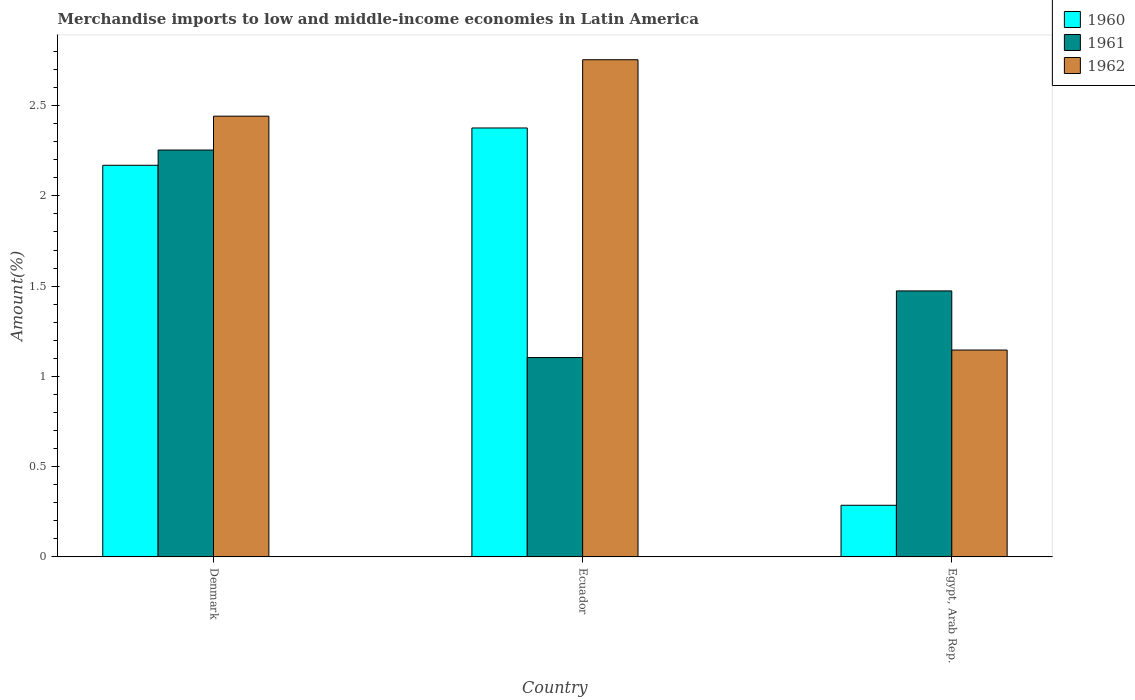Are the number of bars on each tick of the X-axis equal?
Your answer should be compact. Yes. What is the percentage of amount earned from merchandise imports in 1962 in Denmark?
Your response must be concise. 2.44. Across all countries, what is the maximum percentage of amount earned from merchandise imports in 1962?
Your answer should be very brief. 2.75. Across all countries, what is the minimum percentage of amount earned from merchandise imports in 1960?
Your response must be concise. 0.29. In which country was the percentage of amount earned from merchandise imports in 1960 maximum?
Your response must be concise. Ecuador. In which country was the percentage of amount earned from merchandise imports in 1961 minimum?
Give a very brief answer. Ecuador. What is the total percentage of amount earned from merchandise imports in 1960 in the graph?
Your response must be concise. 4.83. What is the difference between the percentage of amount earned from merchandise imports in 1960 in Denmark and that in Egypt, Arab Rep.?
Ensure brevity in your answer.  1.88. What is the difference between the percentage of amount earned from merchandise imports in 1961 in Denmark and the percentage of amount earned from merchandise imports in 1960 in Ecuador?
Ensure brevity in your answer.  -0.12. What is the average percentage of amount earned from merchandise imports in 1960 per country?
Your answer should be compact. 1.61. What is the difference between the percentage of amount earned from merchandise imports of/in 1962 and percentage of amount earned from merchandise imports of/in 1961 in Egypt, Arab Rep.?
Keep it short and to the point. -0.33. What is the ratio of the percentage of amount earned from merchandise imports in 1961 in Denmark to that in Ecuador?
Offer a terse response. 2.04. Is the percentage of amount earned from merchandise imports in 1960 in Denmark less than that in Egypt, Arab Rep.?
Your answer should be compact. No. What is the difference between the highest and the second highest percentage of amount earned from merchandise imports in 1962?
Offer a very short reply. -1.61. What is the difference between the highest and the lowest percentage of amount earned from merchandise imports in 1961?
Ensure brevity in your answer.  1.15. How many bars are there?
Make the answer very short. 9. How many countries are there in the graph?
Offer a very short reply. 3. What is the difference between two consecutive major ticks on the Y-axis?
Keep it short and to the point. 0.5. Are the values on the major ticks of Y-axis written in scientific E-notation?
Offer a terse response. No. Does the graph contain grids?
Offer a terse response. No. How many legend labels are there?
Offer a terse response. 3. How are the legend labels stacked?
Offer a very short reply. Vertical. What is the title of the graph?
Offer a very short reply. Merchandise imports to low and middle-income economies in Latin America. Does "1984" appear as one of the legend labels in the graph?
Provide a short and direct response. No. What is the label or title of the X-axis?
Give a very brief answer. Country. What is the label or title of the Y-axis?
Provide a short and direct response. Amount(%). What is the Amount(%) of 1960 in Denmark?
Give a very brief answer. 2.17. What is the Amount(%) of 1961 in Denmark?
Keep it short and to the point. 2.25. What is the Amount(%) in 1962 in Denmark?
Your response must be concise. 2.44. What is the Amount(%) in 1960 in Ecuador?
Your answer should be very brief. 2.38. What is the Amount(%) in 1961 in Ecuador?
Offer a very short reply. 1.1. What is the Amount(%) of 1962 in Ecuador?
Offer a terse response. 2.75. What is the Amount(%) in 1960 in Egypt, Arab Rep.?
Keep it short and to the point. 0.29. What is the Amount(%) of 1961 in Egypt, Arab Rep.?
Provide a short and direct response. 1.47. What is the Amount(%) of 1962 in Egypt, Arab Rep.?
Your answer should be compact. 1.15. Across all countries, what is the maximum Amount(%) of 1960?
Your answer should be very brief. 2.38. Across all countries, what is the maximum Amount(%) of 1961?
Give a very brief answer. 2.25. Across all countries, what is the maximum Amount(%) in 1962?
Make the answer very short. 2.75. Across all countries, what is the minimum Amount(%) of 1960?
Keep it short and to the point. 0.29. Across all countries, what is the minimum Amount(%) in 1961?
Offer a very short reply. 1.1. Across all countries, what is the minimum Amount(%) of 1962?
Ensure brevity in your answer.  1.15. What is the total Amount(%) of 1960 in the graph?
Make the answer very short. 4.83. What is the total Amount(%) of 1961 in the graph?
Give a very brief answer. 4.83. What is the total Amount(%) in 1962 in the graph?
Keep it short and to the point. 6.34. What is the difference between the Amount(%) in 1960 in Denmark and that in Ecuador?
Keep it short and to the point. -0.21. What is the difference between the Amount(%) of 1961 in Denmark and that in Ecuador?
Keep it short and to the point. 1.15. What is the difference between the Amount(%) of 1962 in Denmark and that in Ecuador?
Offer a terse response. -0.31. What is the difference between the Amount(%) of 1960 in Denmark and that in Egypt, Arab Rep.?
Make the answer very short. 1.88. What is the difference between the Amount(%) in 1961 in Denmark and that in Egypt, Arab Rep.?
Your answer should be compact. 0.78. What is the difference between the Amount(%) of 1962 in Denmark and that in Egypt, Arab Rep.?
Provide a short and direct response. 1.3. What is the difference between the Amount(%) of 1960 in Ecuador and that in Egypt, Arab Rep.?
Keep it short and to the point. 2.09. What is the difference between the Amount(%) in 1961 in Ecuador and that in Egypt, Arab Rep.?
Make the answer very short. -0.37. What is the difference between the Amount(%) in 1962 in Ecuador and that in Egypt, Arab Rep.?
Offer a very short reply. 1.61. What is the difference between the Amount(%) in 1960 in Denmark and the Amount(%) in 1961 in Ecuador?
Provide a short and direct response. 1.07. What is the difference between the Amount(%) in 1960 in Denmark and the Amount(%) in 1962 in Ecuador?
Offer a terse response. -0.58. What is the difference between the Amount(%) of 1961 in Denmark and the Amount(%) of 1962 in Ecuador?
Offer a terse response. -0.5. What is the difference between the Amount(%) in 1960 in Denmark and the Amount(%) in 1961 in Egypt, Arab Rep.?
Your response must be concise. 0.7. What is the difference between the Amount(%) of 1960 in Denmark and the Amount(%) of 1962 in Egypt, Arab Rep.?
Offer a terse response. 1.02. What is the difference between the Amount(%) of 1961 in Denmark and the Amount(%) of 1962 in Egypt, Arab Rep.?
Offer a terse response. 1.11. What is the difference between the Amount(%) of 1960 in Ecuador and the Amount(%) of 1961 in Egypt, Arab Rep.?
Your response must be concise. 0.9. What is the difference between the Amount(%) in 1960 in Ecuador and the Amount(%) in 1962 in Egypt, Arab Rep.?
Provide a short and direct response. 1.23. What is the difference between the Amount(%) of 1961 in Ecuador and the Amount(%) of 1962 in Egypt, Arab Rep.?
Give a very brief answer. -0.04. What is the average Amount(%) of 1960 per country?
Offer a very short reply. 1.61. What is the average Amount(%) of 1961 per country?
Make the answer very short. 1.61. What is the average Amount(%) of 1962 per country?
Give a very brief answer. 2.11. What is the difference between the Amount(%) in 1960 and Amount(%) in 1961 in Denmark?
Offer a very short reply. -0.08. What is the difference between the Amount(%) of 1960 and Amount(%) of 1962 in Denmark?
Offer a very short reply. -0.27. What is the difference between the Amount(%) in 1961 and Amount(%) in 1962 in Denmark?
Your answer should be very brief. -0.19. What is the difference between the Amount(%) in 1960 and Amount(%) in 1961 in Ecuador?
Provide a succinct answer. 1.27. What is the difference between the Amount(%) in 1960 and Amount(%) in 1962 in Ecuador?
Offer a terse response. -0.38. What is the difference between the Amount(%) in 1961 and Amount(%) in 1962 in Ecuador?
Make the answer very short. -1.65. What is the difference between the Amount(%) of 1960 and Amount(%) of 1961 in Egypt, Arab Rep.?
Ensure brevity in your answer.  -1.19. What is the difference between the Amount(%) in 1960 and Amount(%) in 1962 in Egypt, Arab Rep.?
Make the answer very short. -0.86. What is the difference between the Amount(%) of 1961 and Amount(%) of 1962 in Egypt, Arab Rep.?
Provide a succinct answer. 0.33. What is the ratio of the Amount(%) in 1961 in Denmark to that in Ecuador?
Provide a short and direct response. 2.04. What is the ratio of the Amount(%) in 1962 in Denmark to that in Ecuador?
Keep it short and to the point. 0.89. What is the ratio of the Amount(%) in 1960 in Denmark to that in Egypt, Arab Rep.?
Make the answer very short. 7.58. What is the ratio of the Amount(%) of 1961 in Denmark to that in Egypt, Arab Rep.?
Your response must be concise. 1.53. What is the ratio of the Amount(%) in 1962 in Denmark to that in Egypt, Arab Rep.?
Your response must be concise. 2.13. What is the ratio of the Amount(%) of 1960 in Ecuador to that in Egypt, Arab Rep.?
Provide a succinct answer. 8.3. What is the ratio of the Amount(%) of 1961 in Ecuador to that in Egypt, Arab Rep.?
Your response must be concise. 0.75. What is the ratio of the Amount(%) in 1962 in Ecuador to that in Egypt, Arab Rep.?
Your answer should be compact. 2.4. What is the difference between the highest and the second highest Amount(%) in 1960?
Offer a very short reply. 0.21. What is the difference between the highest and the second highest Amount(%) in 1961?
Give a very brief answer. 0.78. What is the difference between the highest and the second highest Amount(%) in 1962?
Give a very brief answer. 0.31. What is the difference between the highest and the lowest Amount(%) in 1960?
Give a very brief answer. 2.09. What is the difference between the highest and the lowest Amount(%) in 1961?
Your response must be concise. 1.15. What is the difference between the highest and the lowest Amount(%) of 1962?
Your answer should be compact. 1.61. 